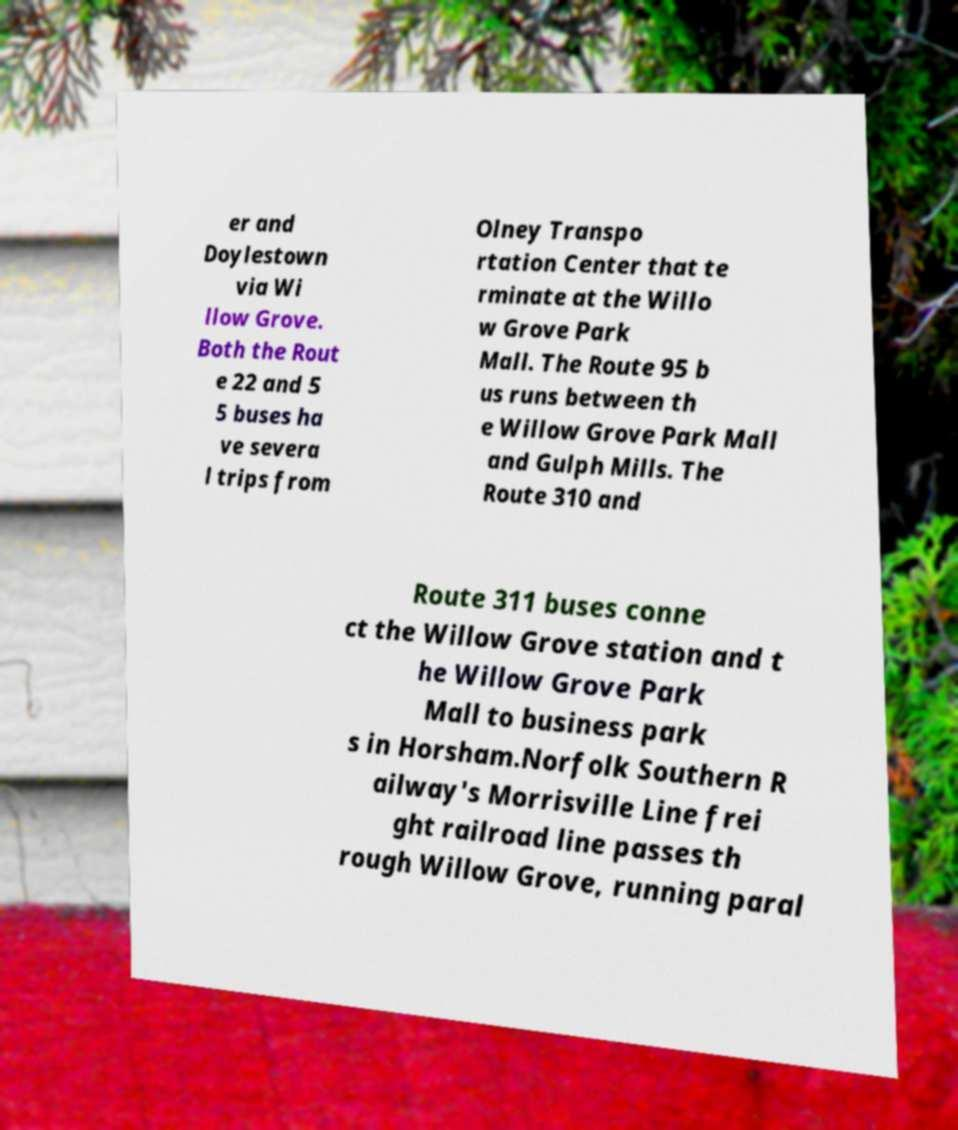Can you accurately transcribe the text from the provided image for me? er and Doylestown via Wi llow Grove. Both the Rout e 22 and 5 5 buses ha ve severa l trips from Olney Transpo rtation Center that te rminate at the Willo w Grove Park Mall. The Route 95 b us runs between th e Willow Grove Park Mall and Gulph Mills. The Route 310 and Route 311 buses conne ct the Willow Grove station and t he Willow Grove Park Mall to business park s in Horsham.Norfolk Southern R ailway's Morrisville Line frei ght railroad line passes th rough Willow Grove, running paral 